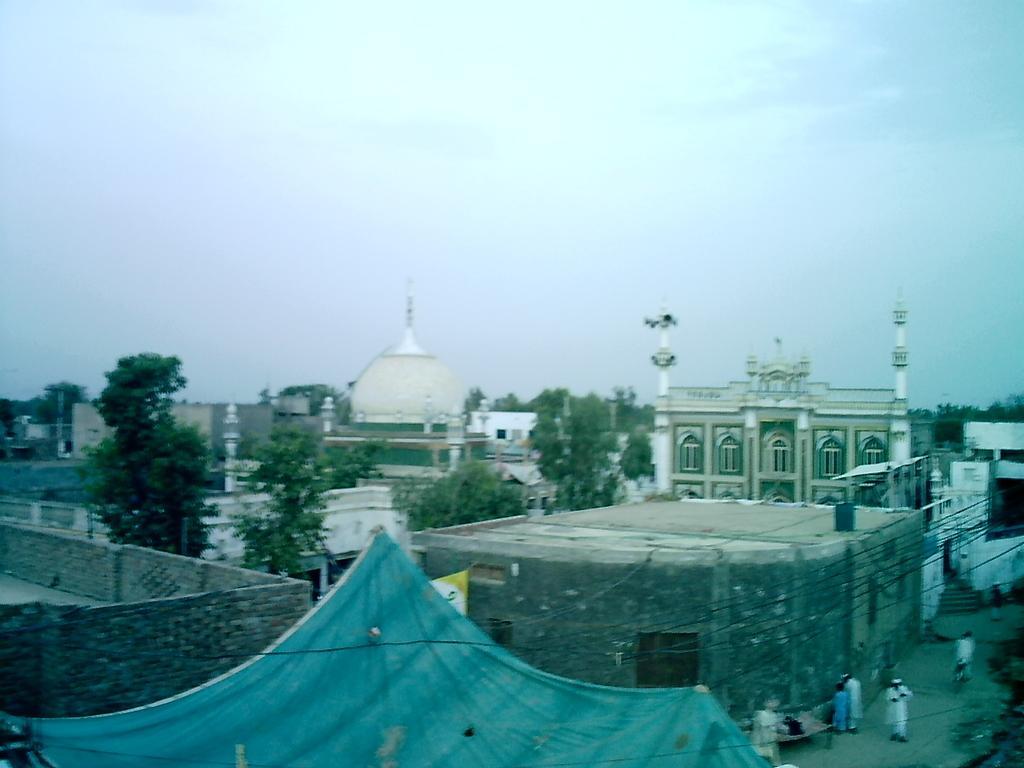In one or two sentences, can you explain what this image depicts? In this picture we can see few buildings, cables and few people, in the background we can see few trees and clouds. 